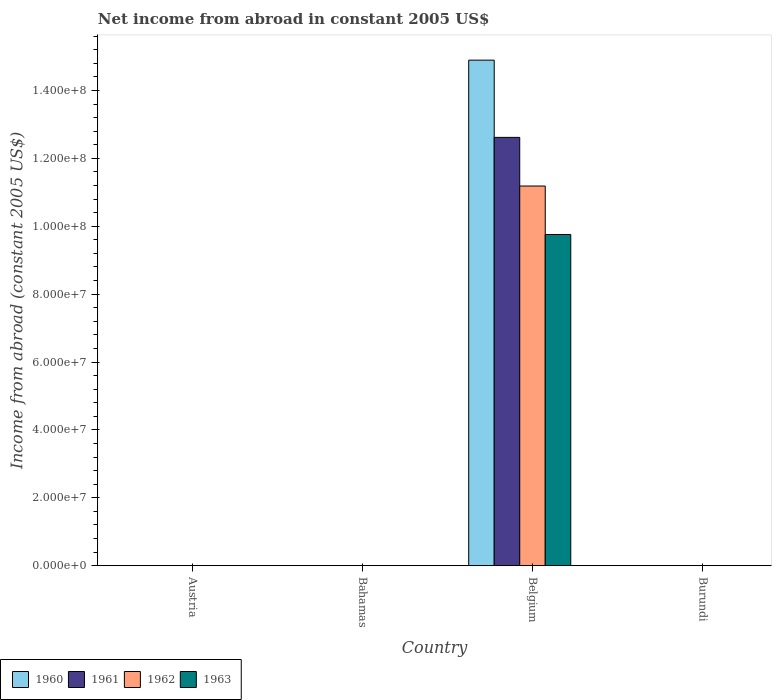How many different coloured bars are there?
Provide a succinct answer. 4. How many bars are there on the 4th tick from the left?
Offer a very short reply. 0. What is the label of the 2nd group of bars from the left?
Your answer should be compact. Bahamas. Across all countries, what is the maximum net income from abroad in 1962?
Your response must be concise. 1.12e+08. What is the total net income from abroad in 1961 in the graph?
Your answer should be compact. 1.26e+08. What is the difference between the net income from abroad in 1960 in Bahamas and the net income from abroad in 1962 in Austria?
Ensure brevity in your answer.  0. What is the average net income from abroad in 1962 per country?
Your response must be concise. 2.80e+07. What is the difference between the net income from abroad of/in 1963 and net income from abroad of/in 1961 in Belgium?
Give a very brief answer. -2.86e+07. What is the difference between the highest and the lowest net income from abroad in 1962?
Give a very brief answer. 1.12e+08. Is it the case that in every country, the sum of the net income from abroad in 1963 and net income from abroad in 1961 is greater than the sum of net income from abroad in 1960 and net income from abroad in 1962?
Keep it short and to the point. No. Is it the case that in every country, the sum of the net income from abroad in 1963 and net income from abroad in 1962 is greater than the net income from abroad in 1961?
Your answer should be very brief. No. Are all the bars in the graph horizontal?
Provide a short and direct response. No. Does the graph contain grids?
Keep it short and to the point. No. Where does the legend appear in the graph?
Make the answer very short. Bottom left. How many legend labels are there?
Your response must be concise. 4. How are the legend labels stacked?
Make the answer very short. Horizontal. What is the title of the graph?
Offer a very short reply. Net income from abroad in constant 2005 US$. Does "2003" appear as one of the legend labels in the graph?
Your answer should be very brief. No. What is the label or title of the Y-axis?
Offer a very short reply. Income from abroad (constant 2005 US$). What is the Income from abroad (constant 2005 US$) in 1960 in Austria?
Give a very brief answer. 0. What is the Income from abroad (constant 2005 US$) in 1961 in Austria?
Make the answer very short. 0. What is the Income from abroad (constant 2005 US$) in 1962 in Austria?
Provide a succinct answer. 0. What is the Income from abroad (constant 2005 US$) of 1963 in Austria?
Keep it short and to the point. 0. What is the Income from abroad (constant 2005 US$) of 1960 in Bahamas?
Your response must be concise. 0. What is the Income from abroad (constant 2005 US$) of 1961 in Bahamas?
Offer a terse response. 0. What is the Income from abroad (constant 2005 US$) in 1960 in Belgium?
Keep it short and to the point. 1.49e+08. What is the Income from abroad (constant 2005 US$) of 1961 in Belgium?
Your answer should be very brief. 1.26e+08. What is the Income from abroad (constant 2005 US$) of 1962 in Belgium?
Provide a succinct answer. 1.12e+08. What is the Income from abroad (constant 2005 US$) in 1963 in Belgium?
Provide a short and direct response. 9.76e+07. What is the Income from abroad (constant 2005 US$) in 1960 in Burundi?
Keep it short and to the point. 0. What is the Income from abroad (constant 2005 US$) in 1962 in Burundi?
Ensure brevity in your answer.  0. What is the Income from abroad (constant 2005 US$) in 1963 in Burundi?
Provide a succinct answer. 0. Across all countries, what is the maximum Income from abroad (constant 2005 US$) of 1960?
Your response must be concise. 1.49e+08. Across all countries, what is the maximum Income from abroad (constant 2005 US$) of 1961?
Offer a very short reply. 1.26e+08. Across all countries, what is the maximum Income from abroad (constant 2005 US$) of 1962?
Offer a terse response. 1.12e+08. Across all countries, what is the maximum Income from abroad (constant 2005 US$) in 1963?
Provide a short and direct response. 9.76e+07. Across all countries, what is the minimum Income from abroad (constant 2005 US$) of 1960?
Ensure brevity in your answer.  0. Across all countries, what is the minimum Income from abroad (constant 2005 US$) in 1961?
Offer a very short reply. 0. What is the total Income from abroad (constant 2005 US$) in 1960 in the graph?
Make the answer very short. 1.49e+08. What is the total Income from abroad (constant 2005 US$) of 1961 in the graph?
Keep it short and to the point. 1.26e+08. What is the total Income from abroad (constant 2005 US$) in 1962 in the graph?
Your answer should be very brief. 1.12e+08. What is the total Income from abroad (constant 2005 US$) of 1963 in the graph?
Provide a short and direct response. 9.76e+07. What is the average Income from abroad (constant 2005 US$) of 1960 per country?
Make the answer very short. 3.72e+07. What is the average Income from abroad (constant 2005 US$) in 1961 per country?
Keep it short and to the point. 3.15e+07. What is the average Income from abroad (constant 2005 US$) of 1962 per country?
Offer a terse response. 2.80e+07. What is the average Income from abroad (constant 2005 US$) in 1963 per country?
Make the answer very short. 2.44e+07. What is the difference between the Income from abroad (constant 2005 US$) of 1960 and Income from abroad (constant 2005 US$) of 1961 in Belgium?
Offer a very short reply. 2.27e+07. What is the difference between the Income from abroad (constant 2005 US$) in 1960 and Income from abroad (constant 2005 US$) in 1962 in Belgium?
Provide a short and direct response. 3.71e+07. What is the difference between the Income from abroad (constant 2005 US$) of 1960 and Income from abroad (constant 2005 US$) of 1963 in Belgium?
Your response must be concise. 5.14e+07. What is the difference between the Income from abroad (constant 2005 US$) of 1961 and Income from abroad (constant 2005 US$) of 1962 in Belgium?
Your answer should be very brief. 1.43e+07. What is the difference between the Income from abroad (constant 2005 US$) in 1961 and Income from abroad (constant 2005 US$) in 1963 in Belgium?
Make the answer very short. 2.86e+07. What is the difference between the Income from abroad (constant 2005 US$) in 1962 and Income from abroad (constant 2005 US$) in 1963 in Belgium?
Make the answer very short. 1.43e+07. What is the difference between the highest and the lowest Income from abroad (constant 2005 US$) of 1960?
Ensure brevity in your answer.  1.49e+08. What is the difference between the highest and the lowest Income from abroad (constant 2005 US$) in 1961?
Ensure brevity in your answer.  1.26e+08. What is the difference between the highest and the lowest Income from abroad (constant 2005 US$) of 1962?
Keep it short and to the point. 1.12e+08. What is the difference between the highest and the lowest Income from abroad (constant 2005 US$) in 1963?
Keep it short and to the point. 9.76e+07. 